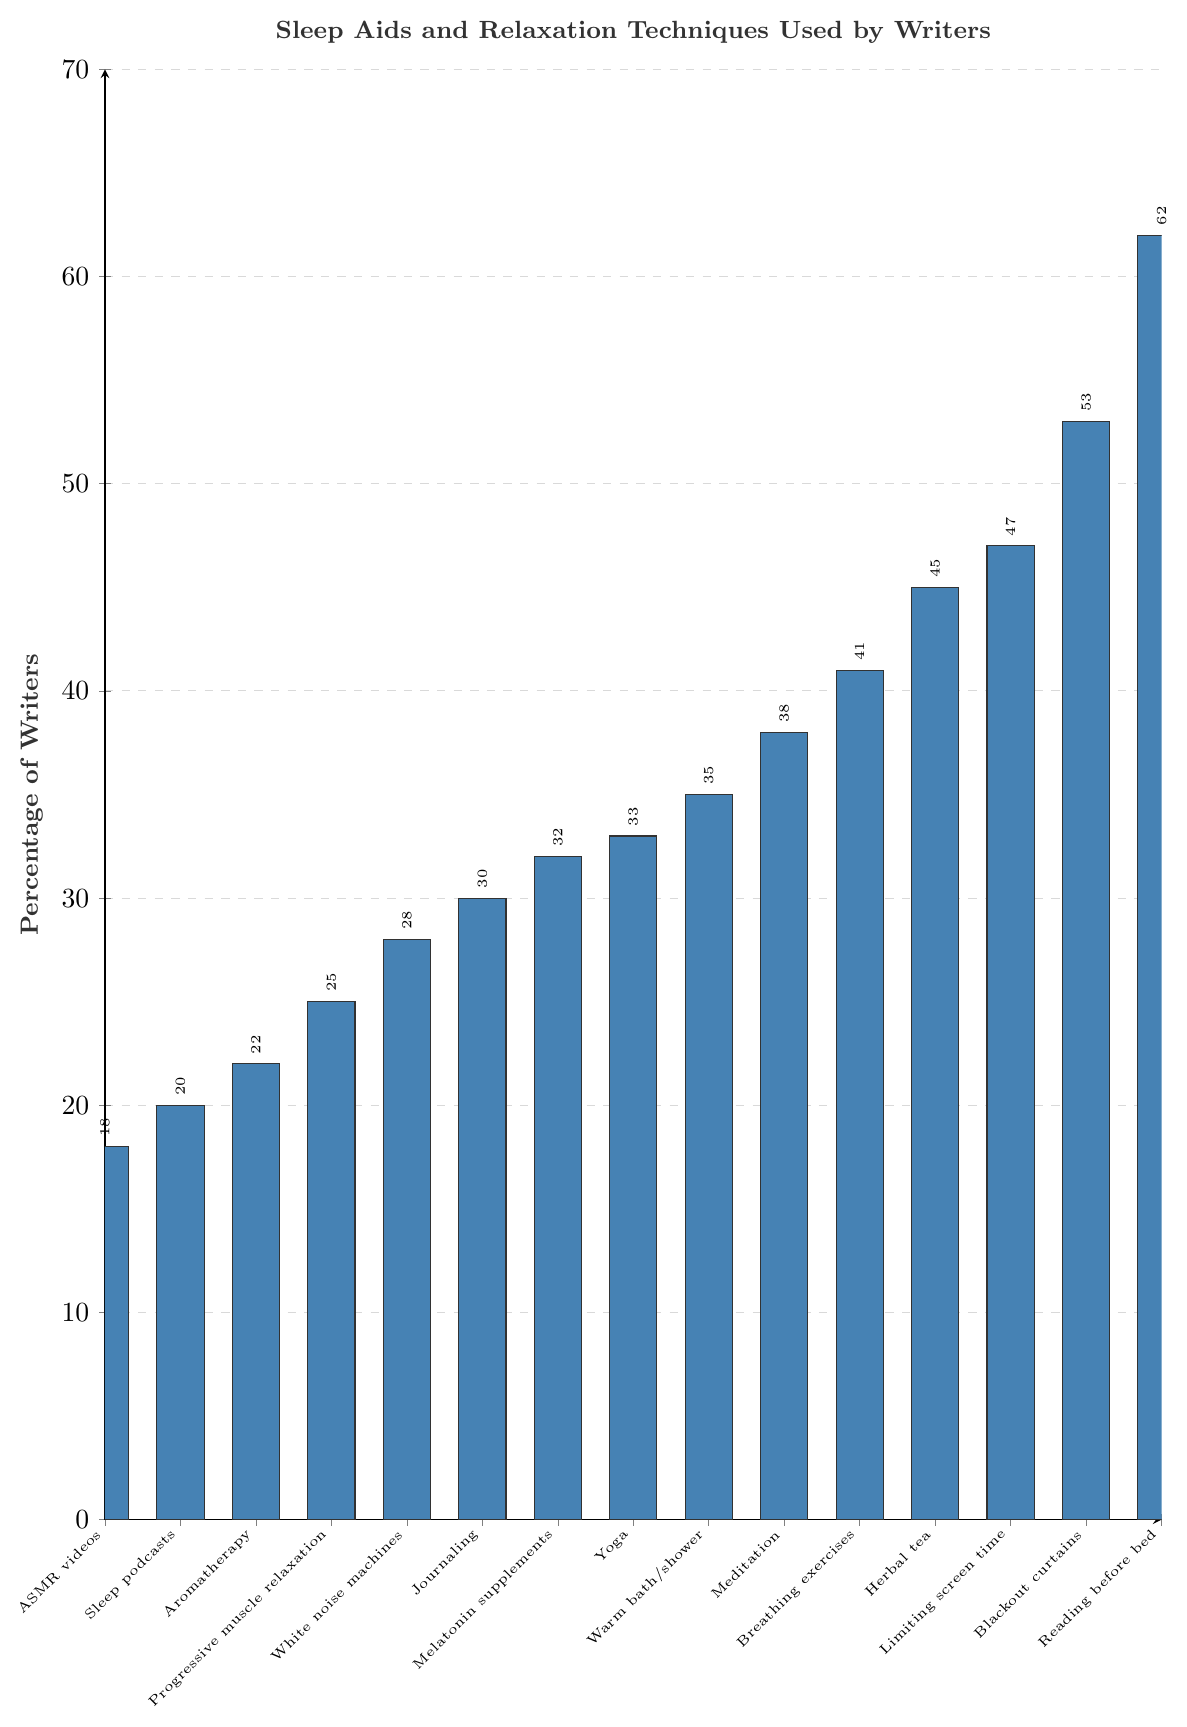What percentage of writers use melatonin supplements compared to those who use herbal tea? The percentage of writers using melatonin supplements is 32%, while the percentage using herbal tea is 45%. By comparing these two values, we see that more writers prefer herbal tea over melatonin supplements for sleep aid.
Answer: Herbal tea, 45%, Melatonin supplements, 32% Which sleep aid has the highest usage among writers? Observing the bars, the tallest bar represents reading before bed. Hence, it has the highest usage among writers, with a percentage of 62%.
Answer: Reading before bed, 62% How many sleep aids are used by at least 40% of writers? To answer this, identify bars with percentages equal to or greater than 40%, which include 'Meditation' (38%), 'Breathing exercises' (41%), 'Herbal tea' (45%), 'Limiting screen time' (47%), 'Blackout curtains' (53%), and 'Reading before bed' (62%). Among these, Meditation is slightly below 40%, while the other five are at or above 40%. Therefore, the total number is five.
Answer: 5 What is the difference in percentage between the least used and most used sleep aids? The least used is ASMR videos (18%), and the most used is reading before bed (62%). The difference is calculated as 62% - 18%.
Answer: 44% Rank the following sleep aids from most to least used: White noise machines, Aromatherapy, Breathing exercises, Journaling By comparing the percentages: Breathing exercises (41%) > White noise machines (28%) > Journaling (30%) > Aromatherapy (22%). Therefore, the rank from most to least used is: Breathing exercises, Journaling, White noise machines, Aromatherapy.
Answer: Breathing exercises, Journaling, White noise machines, Aromatherapy What is the average percentage usage of the listed sleep aids? Sum all percentages: 32+28+45+38+62+22+53+41+35+47+30+25+18+20+33 = 529. There are 15 items, so 529/15 provides the average usage.
Answer: 35.27% Which two sleep aids have the closest percentage usage? Compare the absolute difference between percentages for each pair. The closest values are White noise machines (28%) and Journaling (30%), with a difference of only 2%.
Answer: White noise machines, Journaling How much higher is the usage of blackout curtains compared to ASMR videos? Blackout curtains percentage is 53% and ASMR videos is 18%. The difference is 53% - 18%.
Answer: 35% List the sleep aids that have a usage percentage below 25%. Identify the sleep aids with percentages less than 25%: ASMR videos (18%) and Sleep podcasts (20%).
Answer: ASMR videos, Sleep podcasts What percentage of writers use at least one sleep aid or relaxation technique that has a usage rate above 50%? Identify sleep aids above 50%: Reading before bed (62%) and Blackout curtains (53%). Both percentages are already accounted in the list of used techniques, implying at least one technique used. Therefore, the answer reflects the usage rate of these high-percentage techniques directly.
Answer: 62% 